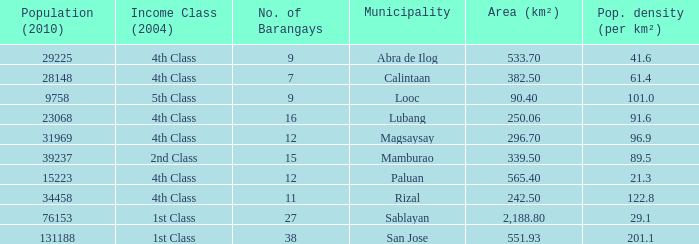What is the population density for the city of lubang? 1.0. 